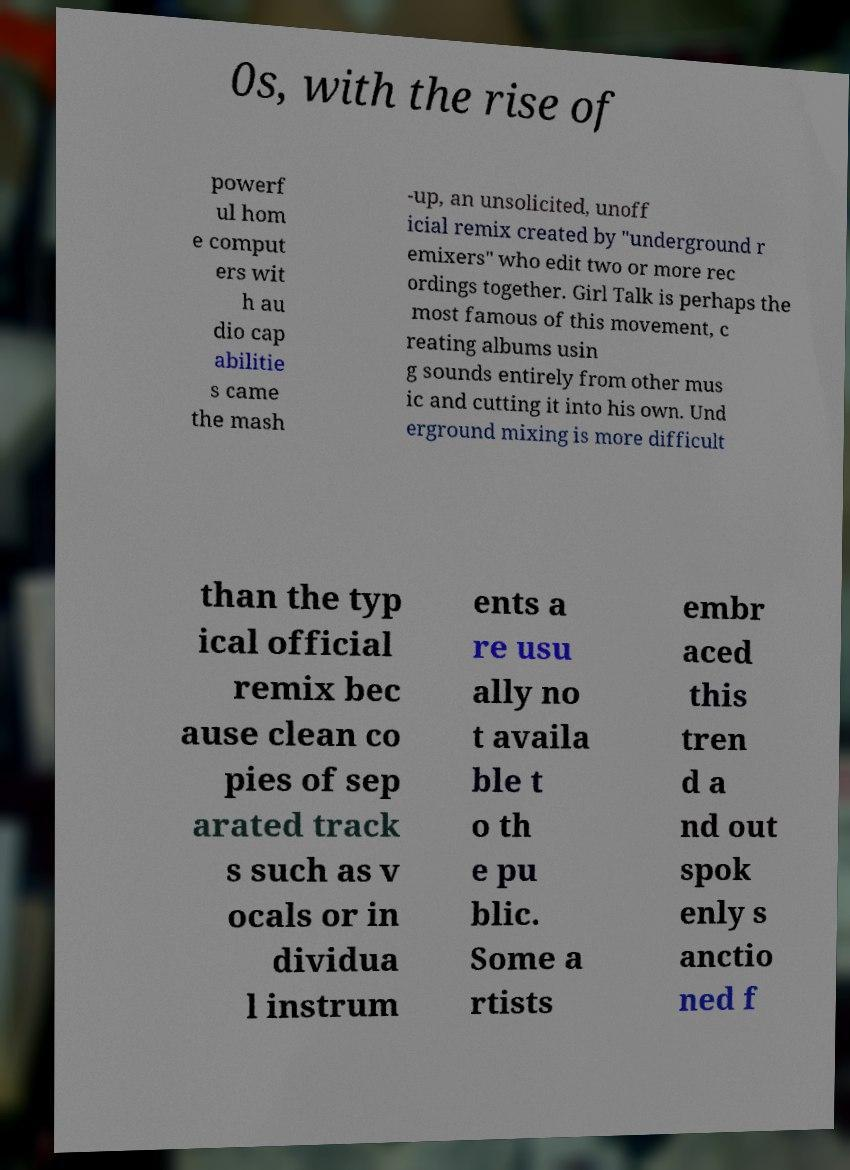For documentation purposes, I need the text within this image transcribed. Could you provide that? 0s, with the rise of powerf ul hom e comput ers wit h au dio cap abilitie s came the mash -up, an unsolicited, unoff icial remix created by "underground r emixers" who edit two or more rec ordings together. Girl Talk is perhaps the most famous of this movement, c reating albums usin g sounds entirely from other mus ic and cutting it into his own. Und erground mixing is more difficult than the typ ical official remix bec ause clean co pies of sep arated track s such as v ocals or in dividua l instrum ents a re usu ally no t availa ble t o th e pu blic. Some a rtists embr aced this tren d a nd out spok enly s anctio ned f 